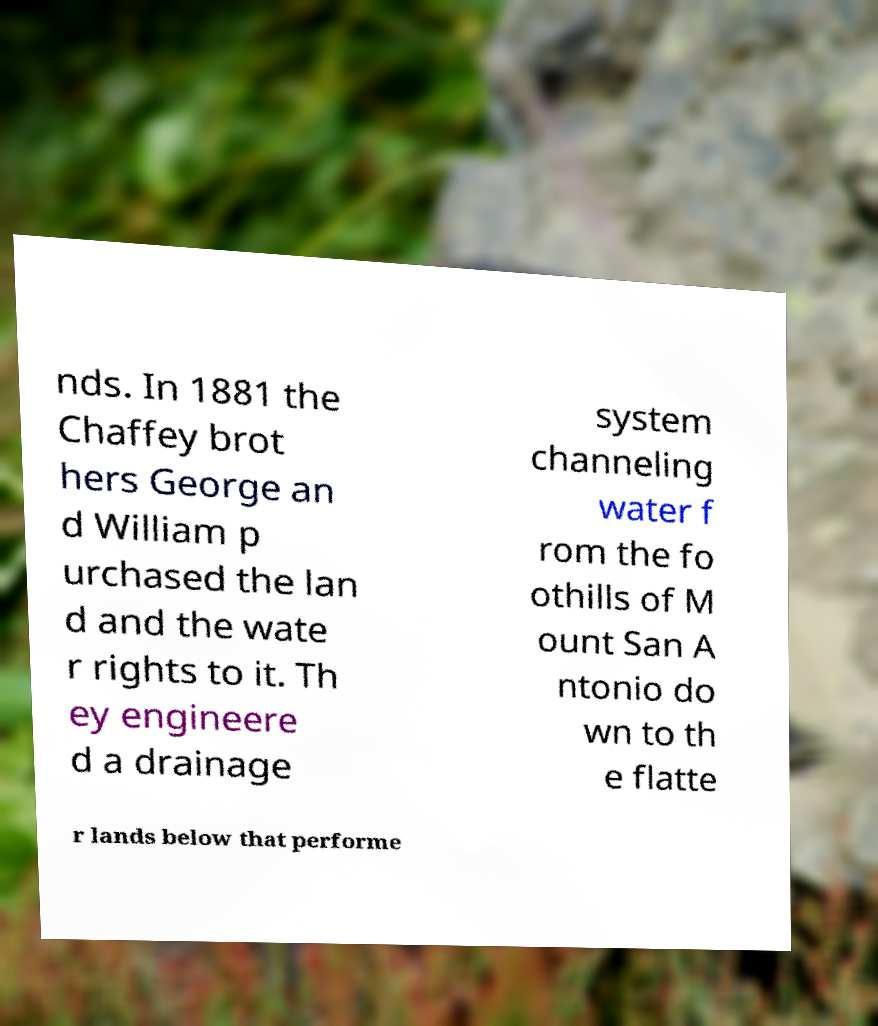Please read and relay the text visible in this image. What does it say? nds. In 1881 the Chaffey brot hers George an d William p urchased the lan d and the wate r rights to it. Th ey engineere d a drainage system channeling water f rom the fo othills of M ount San A ntonio do wn to th e flatte r lands below that performe 